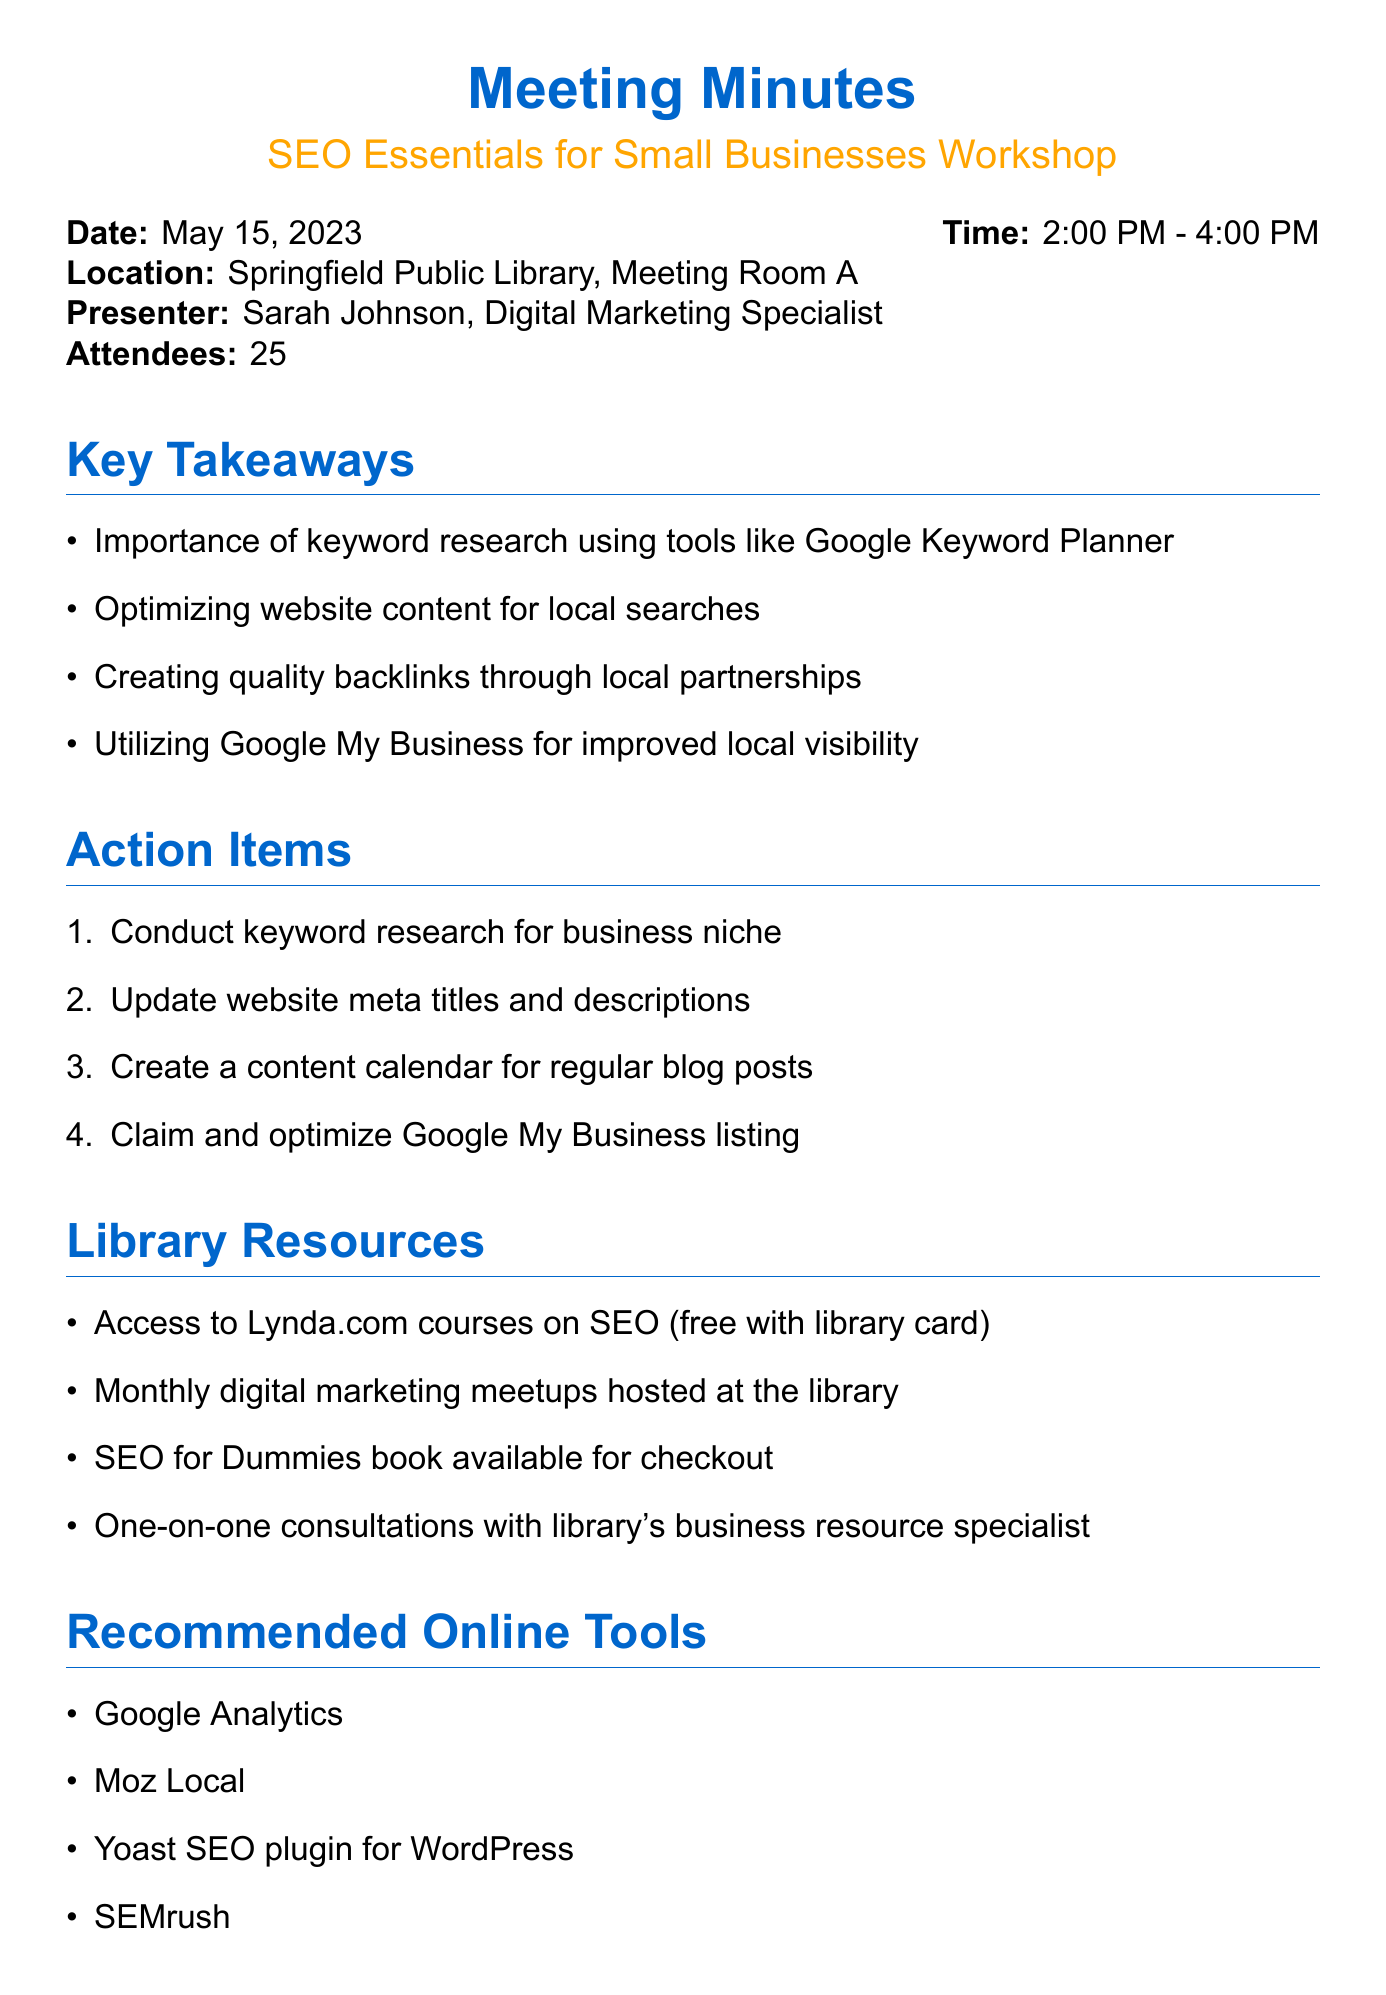What is the workshop title? The workshop title is stated at the beginning of the document under "SEO Essentials for Small Businesses".
Answer: SEO Essentials for Small Businesses Who was the presenter? The presenter's name is mentioned in the document following "Presenter:".
Answer: Sarah Johnson What date did the workshop occur? The date can be found in the document under "Date:".
Answer: May 15, 2023 How many attendees were there? The number of attendees is listed next to "Attendees:".
Answer: 25 What is one key takeaway from the workshop? A key takeaway is listed in the section titled "Key Takeaways".
Answer: Importance of keyword research using tools like Google Keyword Planner What is one action item suggested for participants? Action items can be found under "Action Items" in the document.
Answer: Conduct keyword research for business niche What library resource provides access to SEO courses? The document specifies a library resource that mentions access.
Answer: Access to Lynda.com courses on SEO (free with library card) What is one recommended online tool mentioned? The online tools are listed in a section titled "Recommended Online Tools".
Answer: Google Analytics What feedback percentage rated the workshop as 'very useful'? The feedback section provides a specific statistic regarding ratings.
Answer: 92% 